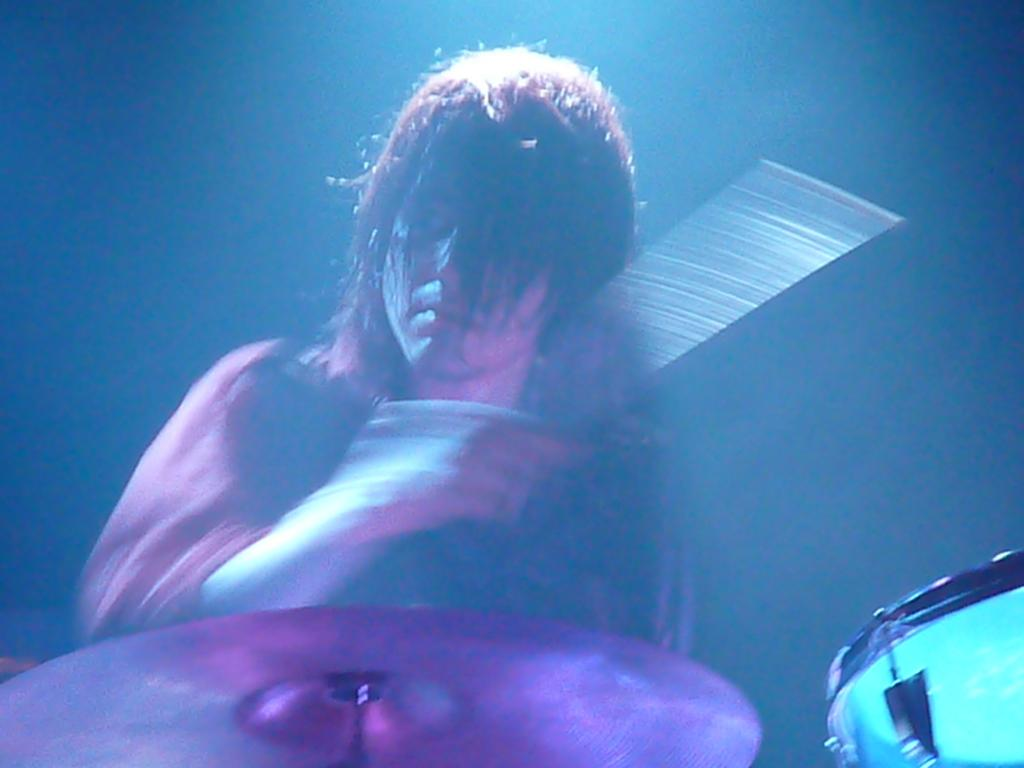What is the main subject of the image? There is a person in the image. What is the person doing in the image? The person is playing drums. Can you describe the lighting conditions in the image? The image was clicked in a dark environment. What type of authority does the person in the image have over the boys? There are no boys present in the image, and the person's authority cannot be determined from the image. Can you see a rake in the image? There is no rake present in the image. 